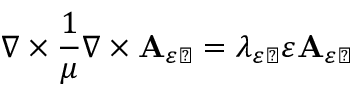Convert formula to latex. <formula><loc_0><loc_0><loc_500><loc_500>\nabla \times \frac { 1 } { \mu } \nabla \times A _ { \varepsilon \perp } = \lambda _ { \varepsilon \perp } \varepsilon A _ { \varepsilon \perp }</formula> 